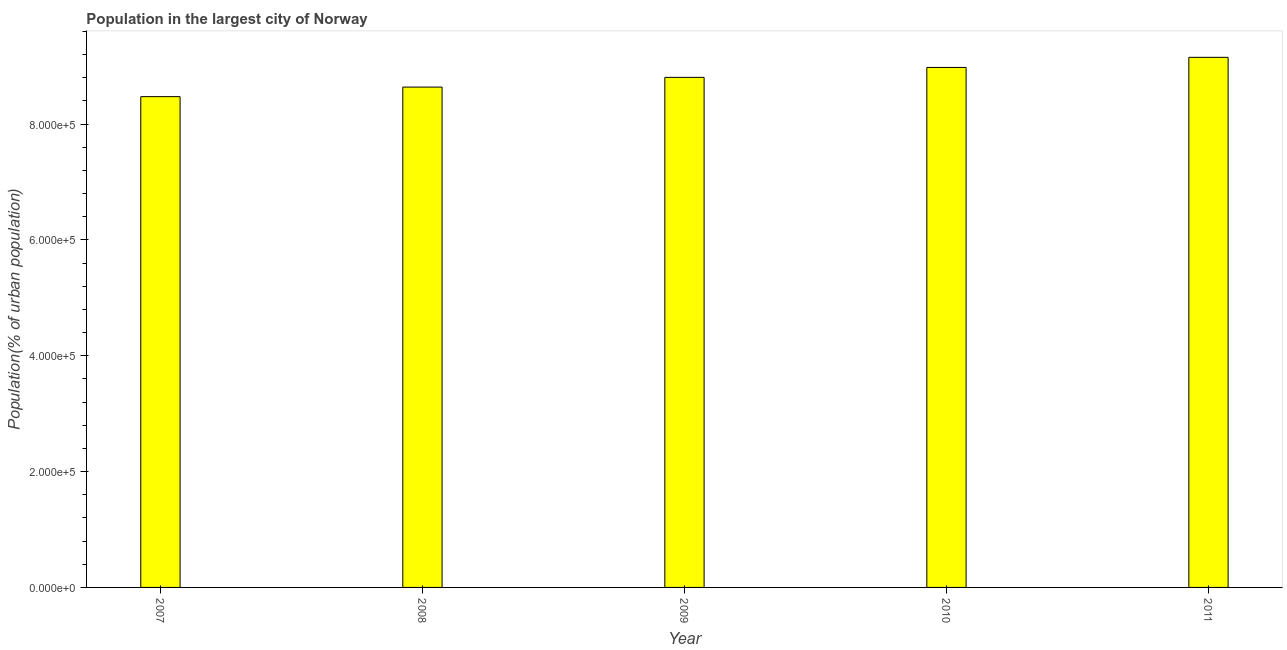What is the title of the graph?
Provide a succinct answer. Population in the largest city of Norway. What is the label or title of the Y-axis?
Provide a short and direct response. Population(% of urban population). What is the population in largest city in 2009?
Your answer should be very brief. 8.81e+05. Across all years, what is the maximum population in largest city?
Make the answer very short. 9.15e+05. Across all years, what is the minimum population in largest city?
Ensure brevity in your answer.  8.47e+05. In which year was the population in largest city minimum?
Provide a succinct answer. 2007. What is the sum of the population in largest city?
Your answer should be compact. 4.41e+06. What is the difference between the population in largest city in 2007 and 2008?
Provide a succinct answer. -1.65e+04. What is the average population in largest city per year?
Ensure brevity in your answer.  8.81e+05. What is the median population in largest city?
Provide a succinct answer. 8.81e+05. In how many years, is the population in largest city greater than 240000 %?
Your answer should be very brief. 5. Do a majority of the years between 2009 and 2011 (inclusive) have population in largest city greater than 200000 %?
Make the answer very short. Yes. What is the ratio of the population in largest city in 2009 to that in 2010?
Offer a very short reply. 0.98. What is the difference between the highest and the second highest population in largest city?
Offer a very short reply. 1.75e+04. What is the difference between the highest and the lowest population in largest city?
Make the answer very short. 6.79e+04. In how many years, is the population in largest city greater than the average population in largest city taken over all years?
Provide a succinct answer. 2. How many bars are there?
Provide a succinct answer. 5. How many years are there in the graph?
Your answer should be compact. 5. What is the difference between two consecutive major ticks on the Y-axis?
Keep it short and to the point. 2.00e+05. What is the Population(% of urban population) of 2007?
Offer a very short reply. 8.47e+05. What is the Population(% of urban population) in 2008?
Give a very brief answer. 8.64e+05. What is the Population(% of urban population) of 2009?
Offer a very short reply. 8.81e+05. What is the Population(% of urban population) of 2010?
Your response must be concise. 8.98e+05. What is the Population(% of urban population) of 2011?
Your answer should be compact. 9.15e+05. What is the difference between the Population(% of urban population) in 2007 and 2008?
Ensure brevity in your answer.  -1.65e+04. What is the difference between the Population(% of urban population) in 2007 and 2009?
Keep it short and to the point. -3.33e+04. What is the difference between the Population(% of urban population) in 2007 and 2010?
Make the answer very short. -5.04e+04. What is the difference between the Population(% of urban population) in 2007 and 2011?
Make the answer very short. -6.79e+04. What is the difference between the Population(% of urban population) in 2008 and 2009?
Keep it short and to the point. -1.68e+04. What is the difference between the Population(% of urban population) in 2008 and 2010?
Ensure brevity in your answer.  -3.39e+04. What is the difference between the Population(% of urban population) in 2008 and 2011?
Your answer should be very brief. -5.14e+04. What is the difference between the Population(% of urban population) in 2009 and 2010?
Keep it short and to the point. -1.71e+04. What is the difference between the Population(% of urban population) in 2009 and 2011?
Make the answer very short. -3.46e+04. What is the difference between the Population(% of urban population) in 2010 and 2011?
Your answer should be very brief. -1.75e+04. What is the ratio of the Population(% of urban population) in 2007 to that in 2010?
Make the answer very short. 0.94. What is the ratio of the Population(% of urban population) in 2007 to that in 2011?
Ensure brevity in your answer.  0.93. What is the ratio of the Population(% of urban population) in 2008 to that in 2011?
Provide a short and direct response. 0.94. What is the ratio of the Population(% of urban population) in 2010 to that in 2011?
Offer a very short reply. 0.98. 